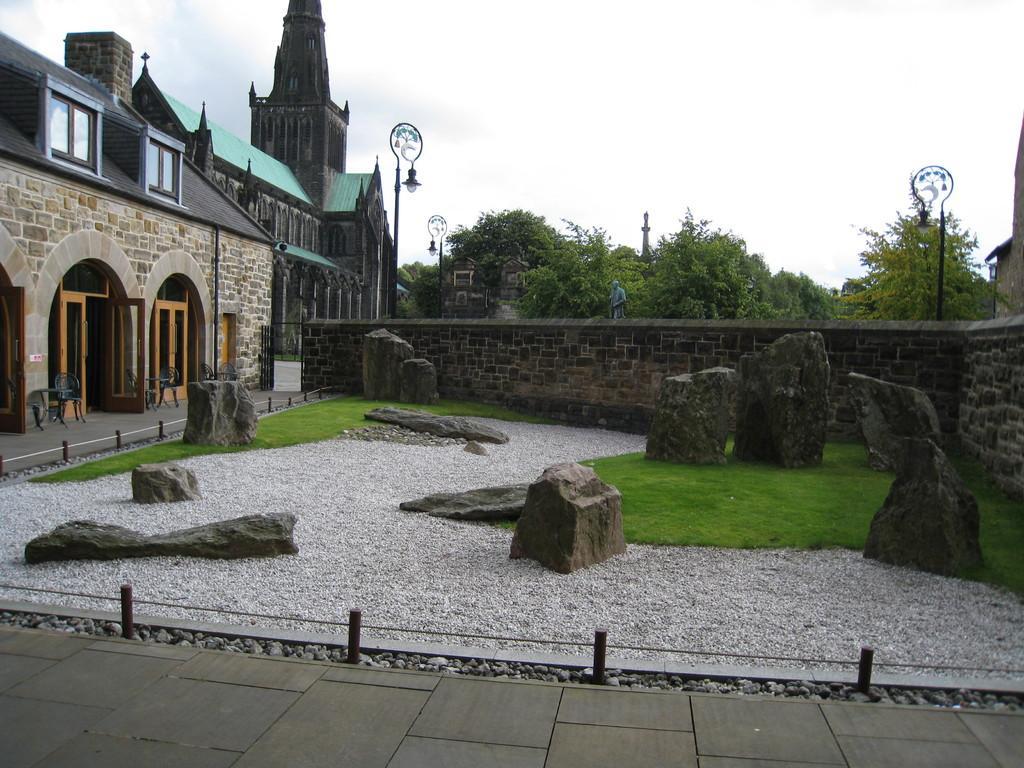In one or two sentences, can you explain what this image depicts? There is a floor near a fencing. In the background, there are rocks, there is a road near grass on the ground, there is wall, buildings which are having glass windows, lights attached to the poles, trees and clouds in the sky. 